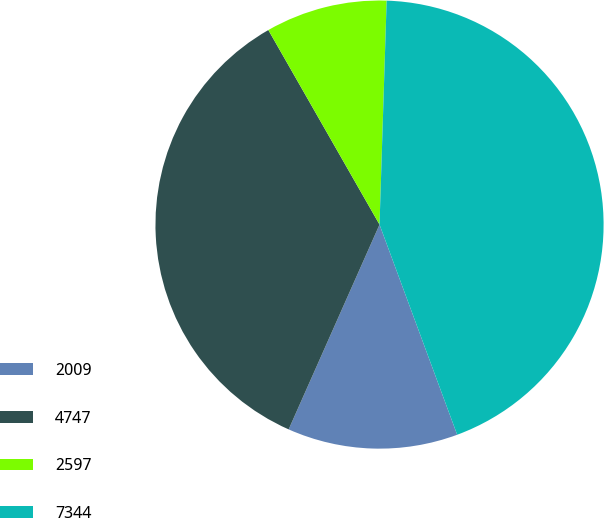<chart> <loc_0><loc_0><loc_500><loc_500><pie_chart><fcel>2009<fcel>4747<fcel>2597<fcel>7344<nl><fcel>12.28%<fcel>35.09%<fcel>8.77%<fcel>43.86%<nl></chart> 